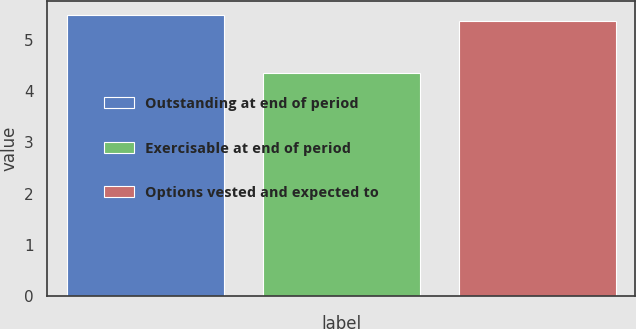Convert chart to OTSL. <chart><loc_0><loc_0><loc_500><loc_500><bar_chart><fcel>Outstanding at end of period<fcel>Exercisable at end of period<fcel>Options vested and expected to<nl><fcel>5.48<fcel>4.36<fcel>5.37<nl></chart> 